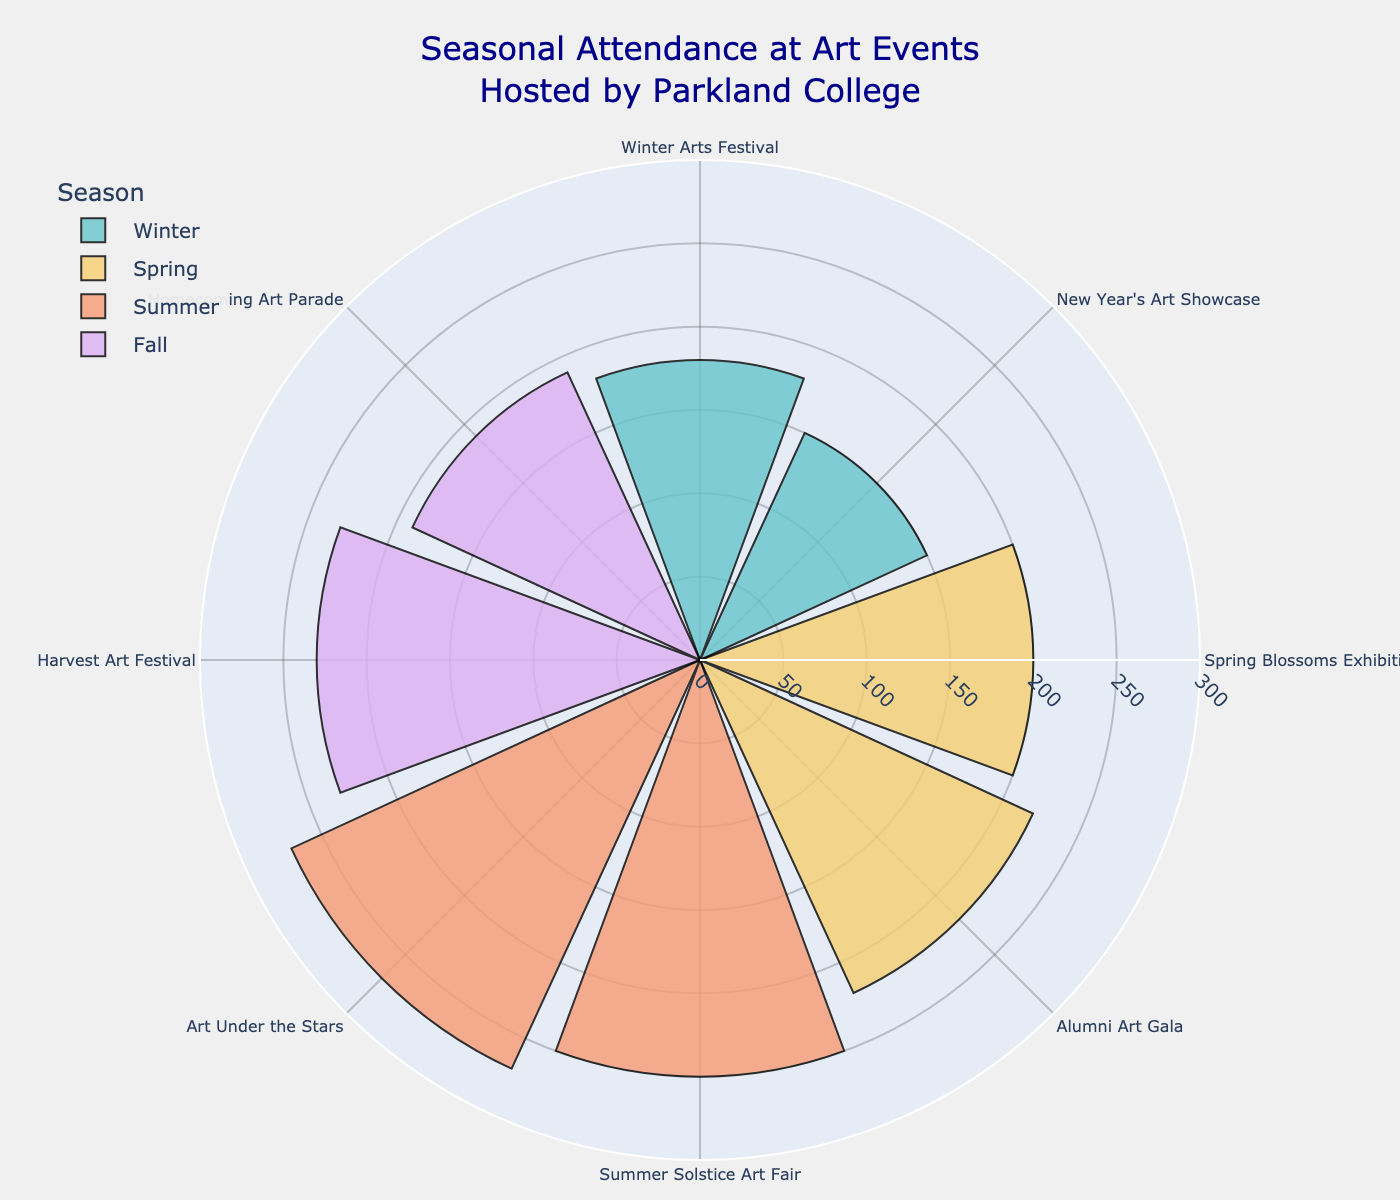What is the title of the chart? The title of the chart is prominently displayed at the top. It reads "Seasonal Attendance at Art Events Hosted by Parkland College".
Answer: Seasonal Attendance at Art Events Hosted by Parkland College How many events are represented in the chart? Each segment on the polar area chart corresponds to an event, and by counting these segments, we can determine there are eight events.
Answer: Eight events Which season has the event with the highest attendance? To identify the season with the highest attendance, look for the longest bar on the chart. The segment representing "Art Under the Stars" during the Summer season has the highest attendance at 270 attendees.
Answer: Summer What is the combined attendance for the Spring events? Sum the attendance of the two Spring events: "Spring Blossoms Exhibition" (200) and "Alumni Art Gala" (220). 200 + 220 = 420.
Answer: 420 Between the Winter and Fall seasons, which has higher total attendance? Add the attendance for each event in Winter (180 + 150) and Fall (230 + 190). Winter: 180 + 150 = 330. Fall: 230 + 190 = 420. Compare the totals: 330 (Winter) vs 420 (Fall).
Answer: Fall What is the difference in attendance between the "Harvest Art Festival" and "Homecoming Art Parade"? Subtract the attendance of "Homecoming Art Parade" (190) from "Harvest Art Festival" (230). 230 - 190 = 40.
Answer: 40 Which event in the Winter season has lower attendance? Compare the attendance of the "Winter Arts Festival" (180) and "New Year's Art Showcase" (150). The "New Year's Art Showcase" has lower attendance.
Answer: New Year's Art Showcase What is the average attendance for the Summer events? Calculate the mean of the attendance for the two Summer events: "Summer Solstice Art Fair" (250) and "Art Under the Stars" (270). (250 + 270) / 2 = 260.
Answer: 260 Which season has the least variation in event attendance? Calculate the range for each season by subtracting the smallest value from the largest. For Winter: 180 - 150 = 30. For Spring: 220 - 200 = 20. For Summer: 270 - 250 = 20. For Fall: 230 - 190 = 40. Spring and Summer both have the least variation with a range of 20.
Answer: Spring and Summer How does the attendance of the "Homecoming Art Parade" compare to the "Alumni Art Gala"? The "Homecoming Art Parade" has 190 attendees while the "Alumni Art Gala" has 220 attendees. Therefore, the "Alumni Art Gala" has 30 more attendees than the "Homecoming Art Parade" (220 - 190 = 30).
Answer: 30 more attendees 